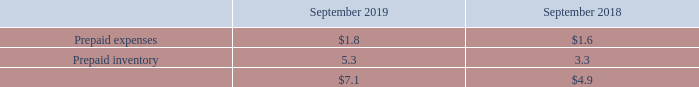(g) Prepaid Expenses and Other Current Assets:
A summary of prepaid expenses and other current assets is as follows (in millions):
Prepaid inventory represents inventory in-transit that has been paid for but not received.
What does prepaid inventory refer to? Inventory in-transit that has been paid for but not received. How much is the company's respective prepaid expenses in 2018 and 2019?
Answer scale should be: million. $1.6, $1.8. How much is the company's respective prepaid inventory in 2018 and 2019?
Answer scale should be: million. 3.3, 5.3. What is the percentage change in the company's total prepaid expenses and other current assets between 2018 and 2019?
Answer scale should be: percent. (7.1 - 4.9)/4.9 
Answer: 44.9. What is the percentage change in the company's prepaid expenses between 2018 and 2019?
Answer scale should be: percent. (1.8 - 1.6)/1.6 
Answer: 12.5. What is the value of the company's 2018 prepaid inventory as a percentage of its total prepaid expenses and other current assets?
Answer scale should be: percent. 3.3/4.9 
Answer: 67.35. 